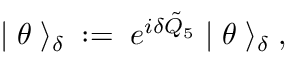Convert formula to latex. <formula><loc_0><loc_0><loc_500><loc_500>| \, \theta \, \rangle _ { \delta } \, \colon = \, e ^ { i \delta \tilde { Q } _ { 5 } } \, | \, \theta \, \rangle _ { \delta } \, ,</formula> 